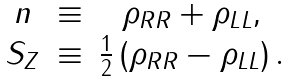Convert formula to latex. <formula><loc_0><loc_0><loc_500><loc_500>\begin{array} { c c c } n & \equiv & \rho _ { R R } + \rho _ { L L } , \\ S _ { Z } & \equiv & \frac { 1 } { 2 } \left ( \rho _ { R R } - \rho _ { L L } \right ) . \end{array}</formula> 